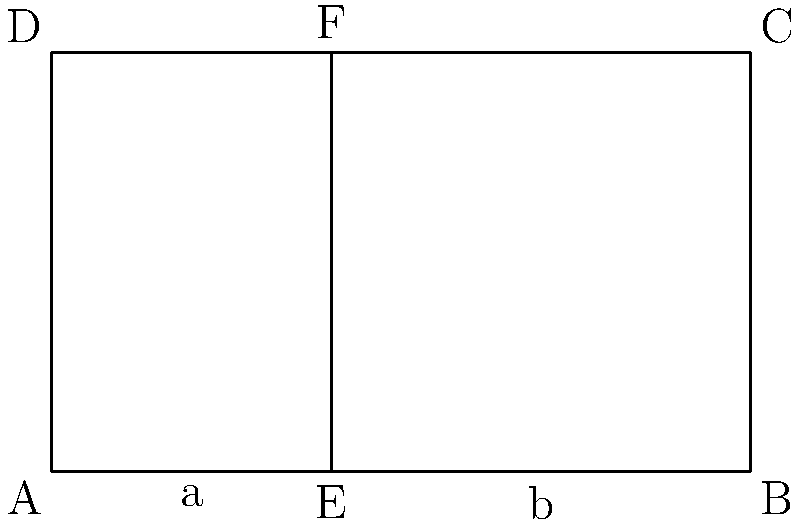In a Baroque facade in Prague, you notice a rectangular section with golden ratio proportions. The width of the entire section is 100 meters, and a vertical line divides it into two parts, as shown in the diagram. If the smaller part (a) is 40 meters wide, calculate the height of the rectangle to maintain the golden ratio. Round your answer to the nearest meter. To solve this problem, we'll follow these steps:

1) The golden ratio is approximately 1.618034. Let's call this φ (phi).

2) In a golden rectangle, the ratio of the longer side to the shorter side is φ.

3) We know the width of the entire rectangle is 100 meters, and it's divided into two parts:
   a = 40 meters
   b = 100 - 40 = 60 meters

4) For the golden ratio to be maintained, we need:
   $\frac{\text{longer side}}{\text{shorter side}} = φ$

5) In this case, that means:
   $\frac{100}{\text{height}} = φ$

6) We can solve this equation:
   $\text{height} = \frac{100}{φ}$

7) Plugging in the value of φ:
   $\text{height} = \frac{100}{1.618034} ≈ 61.8033988749895$

8) Rounding to the nearest meter:
   $\text{height} ≈ 62$ meters

Therefore, the height of the rectangle should be approximately 62 meters to maintain the golden ratio proportion with its width.
Answer: 62 meters 